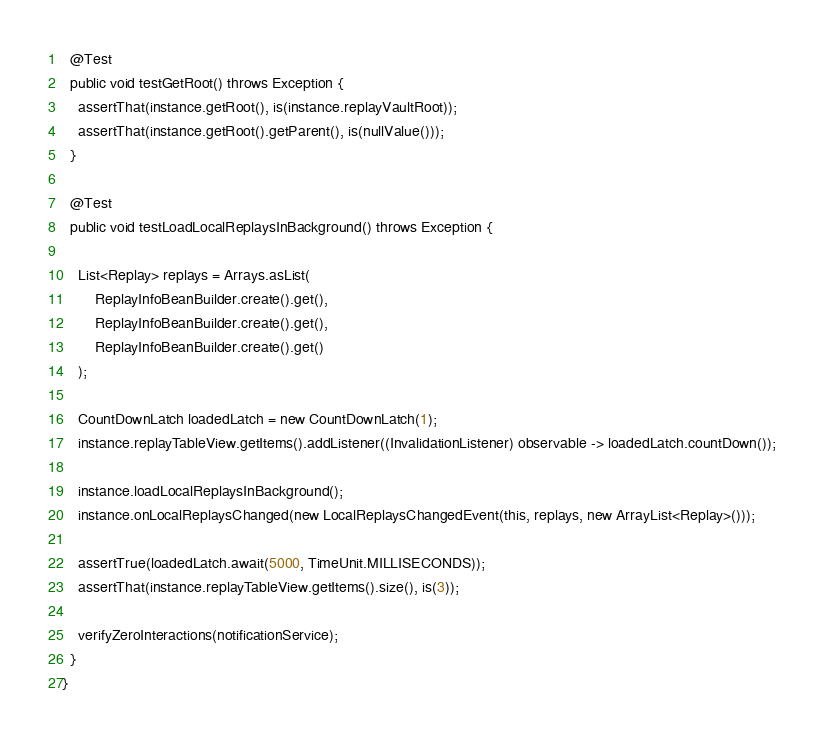Convert code to text. <code><loc_0><loc_0><loc_500><loc_500><_Java_>  @Test
  public void testGetRoot() throws Exception {
    assertThat(instance.getRoot(), is(instance.replayVaultRoot));
    assertThat(instance.getRoot().getParent(), is(nullValue()));
  }

  @Test
  public void testLoadLocalReplaysInBackground() throws Exception {

    List<Replay> replays = Arrays.asList(
        ReplayInfoBeanBuilder.create().get(),
        ReplayInfoBeanBuilder.create().get(),
        ReplayInfoBeanBuilder.create().get()
    );

    CountDownLatch loadedLatch = new CountDownLatch(1);
    instance.replayTableView.getItems().addListener((InvalidationListener) observable -> loadedLatch.countDown());

    instance.loadLocalReplaysInBackground();
    instance.onLocalReplaysChanged(new LocalReplaysChangedEvent(this, replays, new ArrayList<Replay>()));

    assertTrue(loadedLatch.await(5000, TimeUnit.MILLISECONDS));
    assertThat(instance.replayTableView.getItems().size(), is(3));

    verifyZeroInteractions(notificationService);
  }
}
</code> 